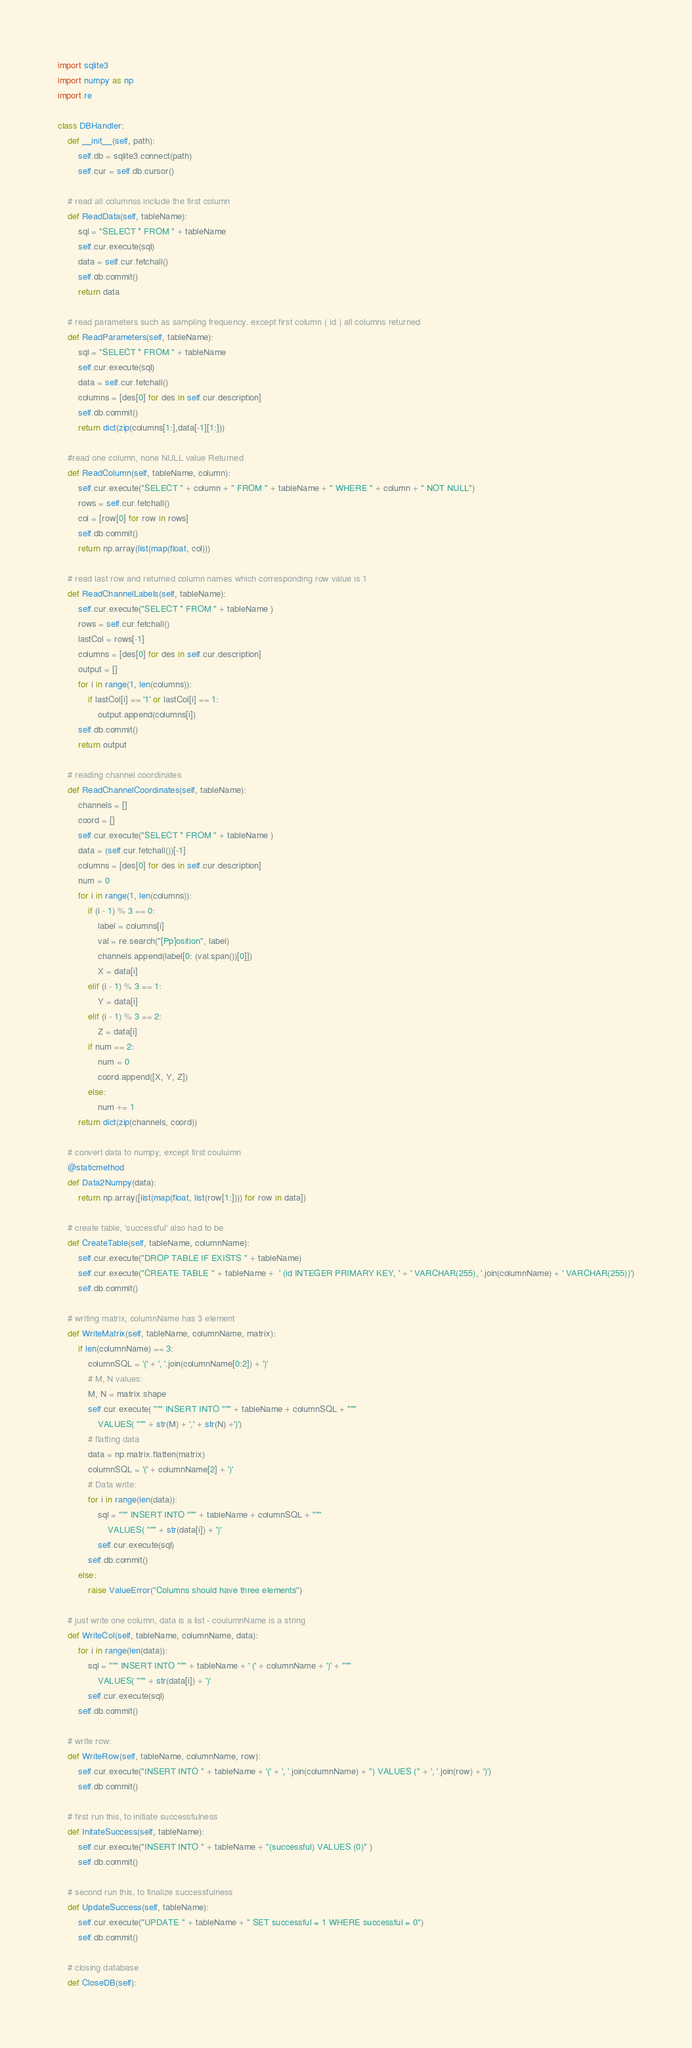<code> <loc_0><loc_0><loc_500><loc_500><_Python_>import sqlite3
import numpy as np
import re

class DBHandler:
    def __init__(self, path):
        self.db = sqlite3.connect(path)
        self.cur = self.db.cursor()

    # read all columnss include the first column
    def ReadData(self, tableName):  
        sql = "SELECT * FROM " + tableName
        self.cur.execute(sql)
        data = self.cur.fetchall()
        self.db.commit()
        return data

    # read parameters such as sampling frequency. except first column ( id ) all columns returned
    def ReadParameters(self, tableName):
        sql = "SELECT * FROM " + tableName
        self.cur.execute(sql)
        data = self.cur.fetchall()
        columns = [des[0] for des in self.cur.description]
        self.db.commit()
        return dict(zip(columns[1:],data[-1][1:]))

    #read one column, none NULL value Returned
    def ReadColumn(self, tableName, column):
        self.cur.execute("SELECT " + column + " FROM " + tableName + " WHERE " + column + " NOT NULL")
        rows = self.cur.fetchall()
        col = [row[0] for row in rows]
        self.db.commit()
        return np.array(list(map(float, col)))

    # read last row and returned column names which corresponding row value is 1
    def ReadChannelLabels(self, tableName):
        self.cur.execute("SELECT * FROM " + tableName )
        rows = self.cur.fetchall()
        lastCol = rows[-1]
        columns = [des[0] for des in self.cur.description]
        output = []
        for i in range(1, len(columns)):
            if lastCol[i] == '1' or lastCol[i] == 1:
                output.append(columns[i])
        self.db.commit()
        return output

    # reading channel coordinates
    def ReadChannelCoordinates(self, tableName):
        channels = []
        coord = []
        self.cur.execute("SELECT * FROM " + tableName )
        data = (self.cur.fetchall())[-1]
        columns = [des[0] for des in self.cur.description]
        num = 0
        for i in range(1, len(columns)):
            if (i - 1) % 3 == 0:
                label = columns[i]
                val = re.search("[Pp]osition", label)
                channels.append(label[0: (val.span())[0]])
                X = data[i]
            elif (i - 1) % 3 == 1:
                Y = data[i]                
            elif (i - 1) % 3 == 2:
                Z = data[i]
            if num == 2:
                num = 0
                coord.append([X, Y, Z])
            else:
                num += 1
        return dict(zip(channels, coord))

    # convert data to numpy, except first couluimn
    @staticmethod
    def Data2Numpy(data):
        return np.array([list(map(float, list(row[1:]))) for row in data])

    # create table, 'successful' also had to be
    def CreateTable(self, tableName, columnName):
        self.cur.execute("DROP TABLE IF EXISTS " + tableName)
        self.cur.execute("CREATE TABLE " + tableName +  ' (id INTEGER PRIMARY KEY, ' + ' VARCHAR(255), '.join(columnName) + ' VARCHAR(255))')
        self.db.commit()

    # writing matrix, columnName has 3 element
    def WriteMatrix(self, tableName, columnName, matrix):
        if len(columnName) == 3:
            columnSQL = '(' + ', '.join(columnName[0:2]) + ')'
            # M, N values:
            M, N = matrix.shape
            self.cur.execute( """ INSERT INTO """ + tableName + columnSQL + """
                VALUES( """ + str(M) + ',' + str(N) +')')
            # flatting data
            data = np.matrix.flatten(matrix)
            columnSQL = '(' + columnName[2] + ')'
            # Data write:
            for i in range(len(data)):
                sql = """ INSERT INTO """ + tableName + columnSQL + """
                    VALUES( """ + str(data[i]) + ')'
                self.cur.execute(sql)
            self.db.commit()
        else:
            raise ValueError("Columns should have three elements") 
    
    # just write one column, data is a list - coulumnName is a string
    def WriteCol(self, tableName, columnName, data):
        for i in range(len(data)):
            sql = """ INSERT INTO """ + tableName + ' (' + columnName + ')' + """
                VALUES( """ + str(data[i]) + ')'
            self.cur.execute(sql)
        self.db.commit()

    # write row:
    def WriteRow(self, tableName, columnName, row):
        self.cur.execute("INSERT INTO " + tableName + '(' + ', '.join(columnName) + ") VALUES (" + ', '.join(row) + ')')
        self.db.commit()

    # first run this, to initiate successfulness
    def InitateSuccess(self, tableName):
        self.cur.execute("INSERT INTO " + tableName + "(successful) VALUES (0)" )
        self.db.commit()

    # second run this, to finalize successfulness
    def UpdateSuccess(self, tableName):
        self.cur.execute("UPDATE " + tableName + " SET successful = 1 WHERE successful = 0")
        self.db.commit()

    # closing database
    def CloseDB(self):</code> 